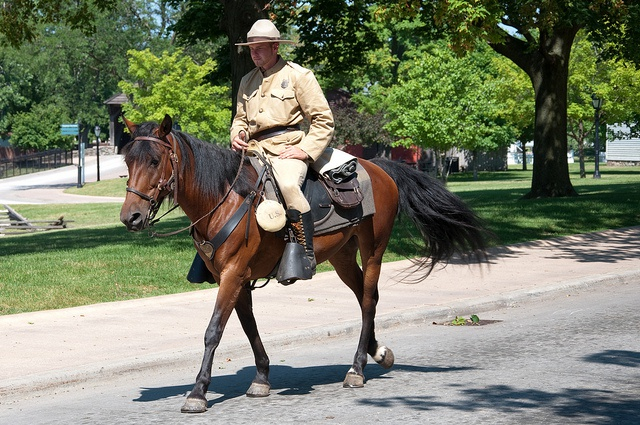Describe the objects in this image and their specific colors. I can see horse in darkgreen, black, gray, and maroon tones and people in darkgreen, beige, tan, black, and gray tones in this image. 